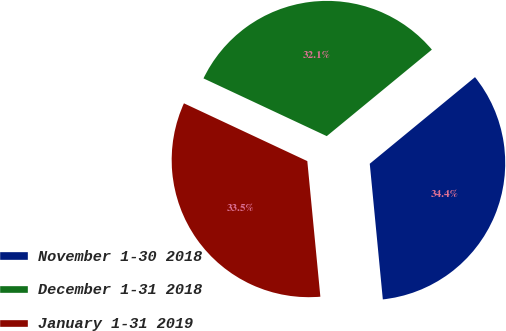Convert chart. <chart><loc_0><loc_0><loc_500><loc_500><pie_chart><fcel>November 1-30 2018<fcel>December 1-31 2018<fcel>January 1-31 2019<nl><fcel>34.43%<fcel>32.07%<fcel>33.5%<nl></chart> 